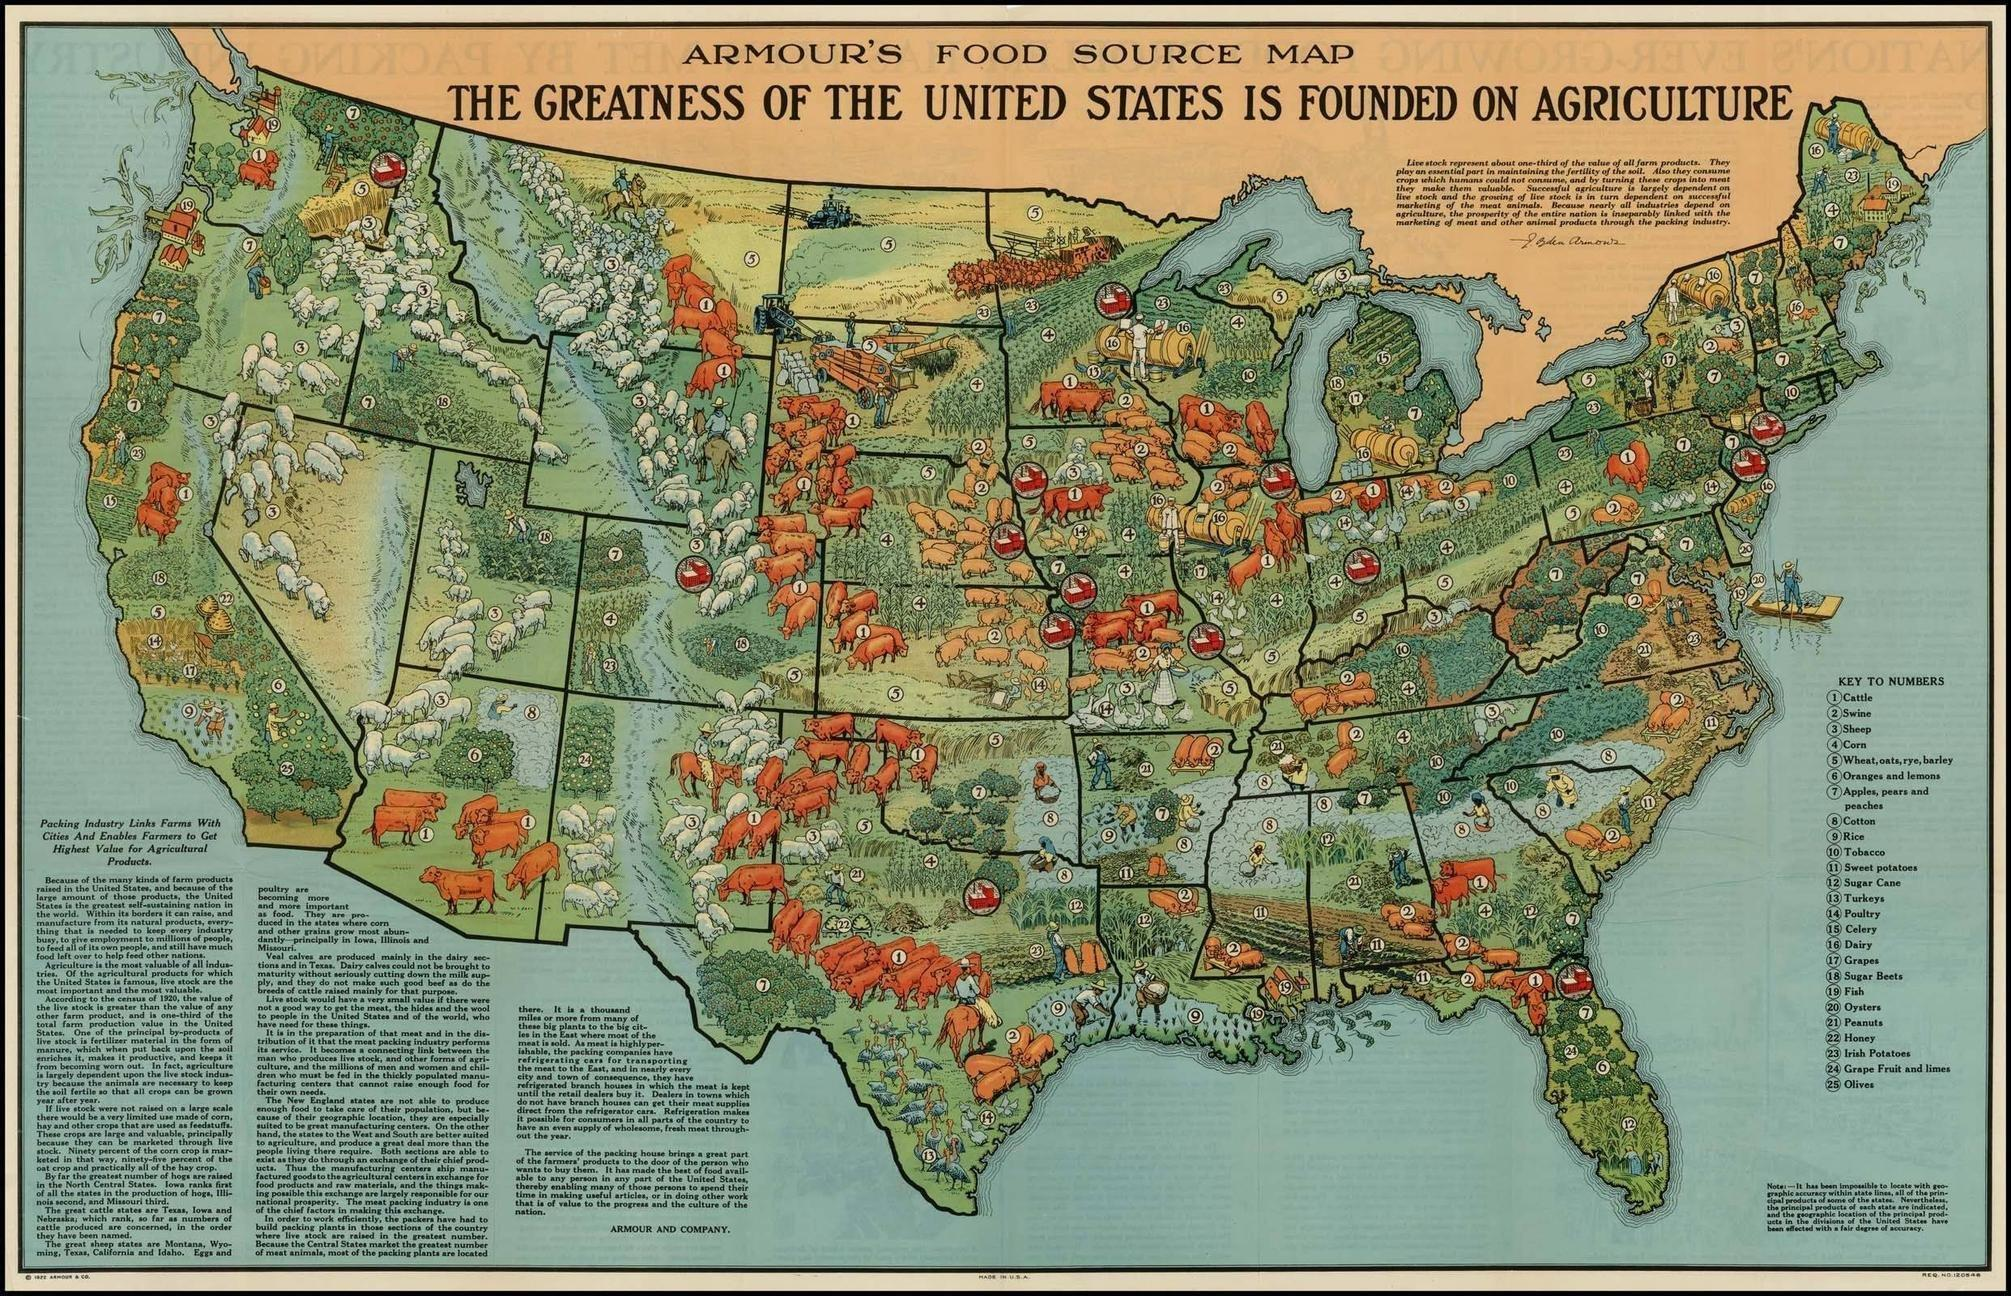Where Veal calves are produced?
Answer the question with a short phrase. Veal calves are produced mainly in the dairy sections and in Texas. How many different items are plotted in this map? 25 